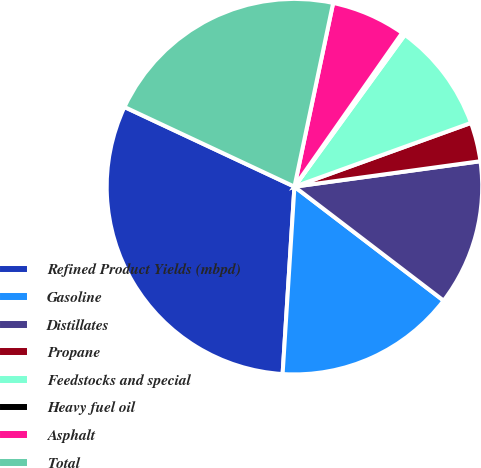<chart> <loc_0><loc_0><loc_500><loc_500><pie_chart><fcel>Refined Product Yields (mbpd)<fcel>Gasoline<fcel>Distillates<fcel>Propane<fcel>Feedstocks and special<fcel>Heavy fuel oil<fcel>Asphalt<fcel>Total<nl><fcel>30.97%<fcel>15.62%<fcel>12.55%<fcel>3.35%<fcel>9.48%<fcel>0.28%<fcel>6.42%<fcel>21.33%<nl></chart> 